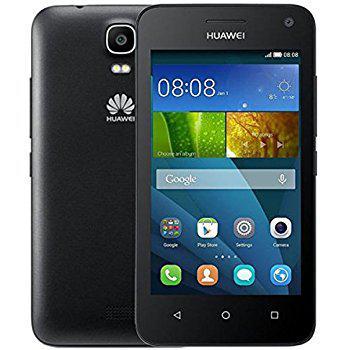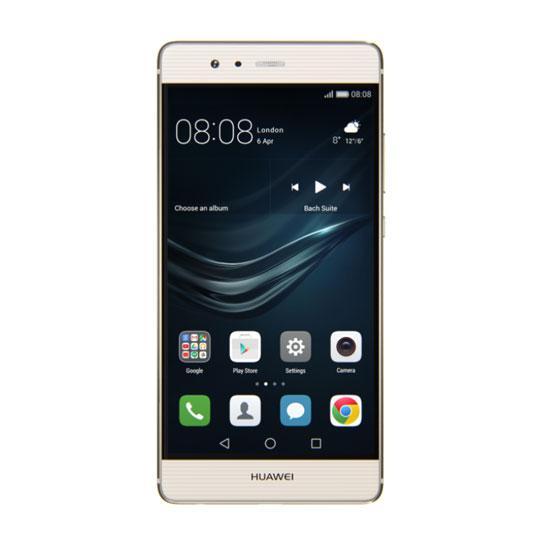The first image is the image on the left, the second image is the image on the right. Assess this claim about the two images: "One image shows the front and the back of a smartphone and the other shows only the front of a smartphone.". Correct or not? Answer yes or no. Yes. The first image is the image on the left, the second image is the image on the right. Examine the images to the left and right. Is the description "The left image shows a phone screen side-up that is on the right and overlapping a back-turned phone, and the right image shows only a phone's screen side." accurate? Answer yes or no. Yes. 